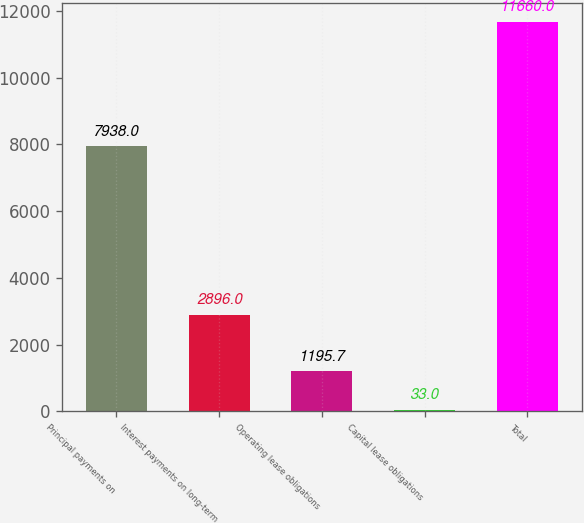Convert chart. <chart><loc_0><loc_0><loc_500><loc_500><bar_chart><fcel>Principal payments on<fcel>Interest payments on long-term<fcel>Operating lease obligations<fcel>Capital lease obligations<fcel>Total<nl><fcel>7938<fcel>2896<fcel>1195.7<fcel>33<fcel>11660<nl></chart> 